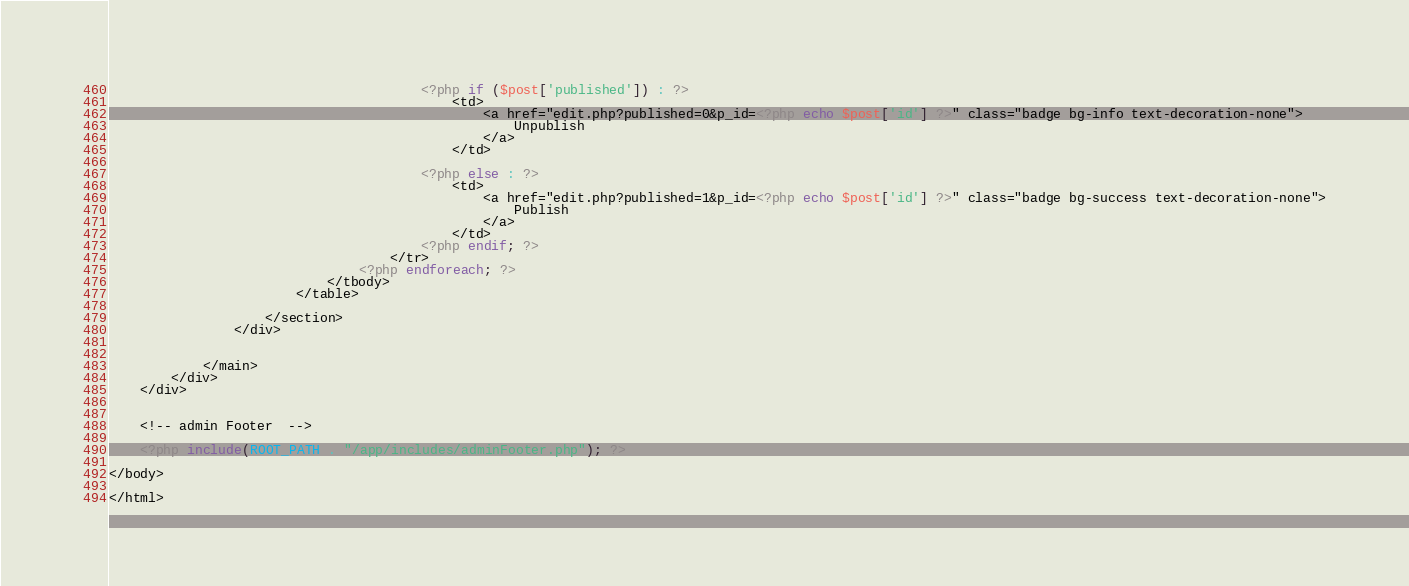<code> <loc_0><loc_0><loc_500><loc_500><_PHP_>                                        <?php if ($post['published']) : ?>
                                            <td>
                                                <a href="edit.php?published=0&p_id=<?php echo $post['id'] ?>" class="badge bg-info text-decoration-none">
                                                    Unpublish
                                                </a>
                                            </td>

                                        <?php else : ?>
                                            <td>
                                                <a href="edit.php?published=1&p_id=<?php echo $post['id'] ?>" class="badge bg-success text-decoration-none">
                                                    Publish
                                                </a>
                                            </td>
                                        <?php endif; ?>
                                    </tr>
                                <?php endforeach; ?>
                            </tbody>
                        </table>

                    </section>
                </div>


            </main>
        </div>
    </div>


    <!-- admin Footer  -->

    <?php include(ROOT_PATH . "/app/includes/adminFooter.php"); ?>

</body>

</html></code> 